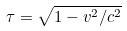<formula> <loc_0><loc_0><loc_500><loc_500>\tau = \sqrt { 1 - v ^ { 2 } / c ^ { 2 } }</formula> 